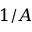Convert formula to latex. <formula><loc_0><loc_0><loc_500><loc_500>1 / A</formula> 